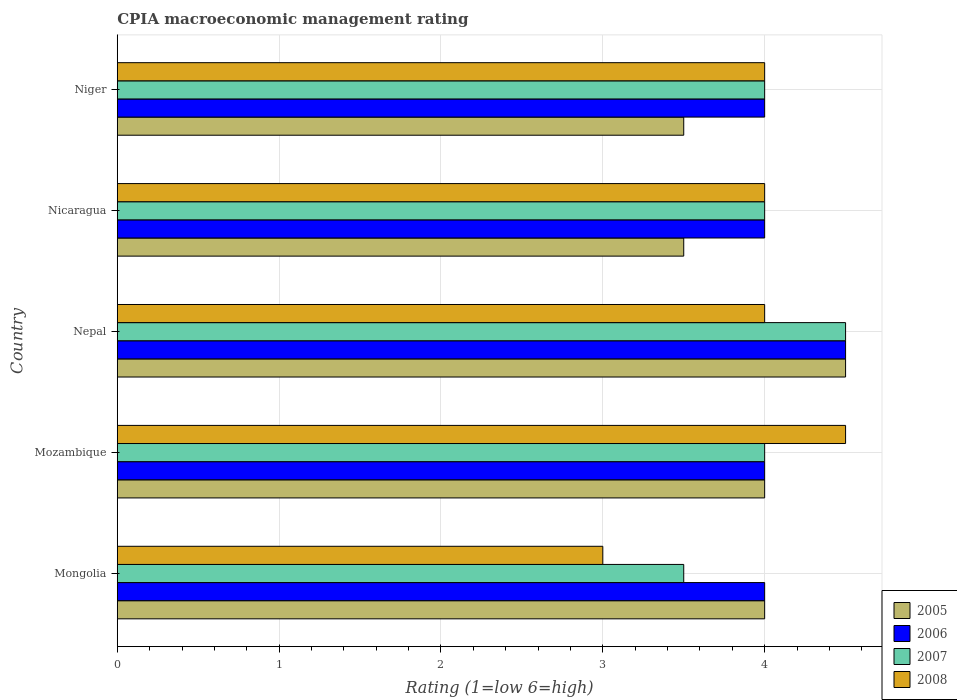Are the number of bars per tick equal to the number of legend labels?
Keep it short and to the point. Yes. How many bars are there on the 1st tick from the top?
Your answer should be compact. 4. What is the label of the 1st group of bars from the top?
Provide a succinct answer. Niger. In how many cases, is the number of bars for a given country not equal to the number of legend labels?
Offer a terse response. 0. In which country was the CPIA rating in 2007 maximum?
Your answer should be very brief. Nepal. In which country was the CPIA rating in 2007 minimum?
Give a very brief answer. Mongolia. What is the total CPIA rating in 2006 in the graph?
Provide a succinct answer. 20.5. In how many countries, is the CPIA rating in 2008 greater than 3 ?
Ensure brevity in your answer.  4. What is the ratio of the CPIA rating in 2005 in Nepal to that in Niger?
Ensure brevity in your answer.  1.29. What is the difference between the highest and the second highest CPIA rating in 2005?
Offer a very short reply. 0.5. What is the difference between the highest and the lowest CPIA rating in 2007?
Ensure brevity in your answer.  1. Is it the case that in every country, the sum of the CPIA rating in 2008 and CPIA rating in 2005 is greater than the sum of CPIA rating in 2006 and CPIA rating in 2007?
Provide a short and direct response. No. What does the 2nd bar from the bottom in Nepal represents?
Make the answer very short. 2006. Is it the case that in every country, the sum of the CPIA rating in 2006 and CPIA rating in 2005 is greater than the CPIA rating in 2007?
Ensure brevity in your answer.  Yes. What is the difference between two consecutive major ticks on the X-axis?
Your answer should be very brief. 1. Are the values on the major ticks of X-axis written in scientific E-notation?
Offer a very short reply. No. Does the graph contain any zero values?
Provide a short and direct response. No. Where does the legend appear in the graph?
Your response must be concise. Bottom right. How many legend labels are there?
Offer a terse response. 4. What is the title of the graph?
Your answer should be compact. CPIA macroeconomic management rating. Does "1993" appear as one of the legend labels in the graph?
Give a very brief answer. No. What is the label or title of the X-axis?
Offer a terse response. Rating (1=low 6=high). What is the Rating (1=low 6=high) in 2005 in Mongolia?
Keep it short and to the point. 4. What is the Rating (1=low 6=high) in 2008 in Mongolia?
Your answer should be compact. 3. What is the Rating (1=low 6=high) of 2007 in Mozambique?
Keep it short and to the point. 4. What is the Rating (1=low 6=high) in 2008 in Mozambique?
Make the answer very short. 4.5. What is the Rating (1=low 6=high) of 2006 in Nepal?
Offer a very short reply. 4.5. What is the Rating (1=low 6=high) of 2005 in Nicaragua?
Your response must be concise. 3.5. What is the Rating (1=low 6=high) in 2006 in Nicaragua?
Ensure brevity in your answer.  4. What is the Rating (1=low 6=high) in 2006 in Niger?
Your response must be concise. 4. What is the Rating (1=low 6=high) in 2008 in Niger?
Provide a succinct answer. 4. Across all countries, what is the maximum Rating (1=low 6=high) in 2006?
Your response must be concise. 4.5. Across all countries, what is the minimum Rating (1=low 6=high) in 2005?
Your response must be concise. 3.5. Across all countries, what is the minimum Rating (1=low 6=high) in 2007?
Your response must be concise. 3.5. What is the total Rating (1=low 6=high) in 2005 in the graph?
Your answer should be compact. 19.5. What is the total Rating (1=low 6=high) in 2006 in the graph?
Your response must be concise. 20.5. What is the difference between the Rating (1=low 6=high) of 2007 in Mongolia and that in Mozambique?
Make the answer very short. -0.5. What is the difference between the Rating (1=low 6=high) in 2005 in Mongolia and that in Nepal?
Offer a very short reply. -0.5. What is the difference between the Rating (1=low 6=high) in 2005 in Mongolia and that in Nicaragua?
Offer a very short reply. 0.5. What is the difference between the Rating (1=low 6=high) in 2005 in Mongolia and that in Niger?
Keep it short and to the point. 0.5. What is the difference between the Rating (1=low 6=high) in 2006 in Mongolia and that in Niger?
Offer a very short reply. 0. What is the difference between the Rating (1=low 6=high) in 2008 in Mongolia and that in Niger?
Your response must be concise. -1. What is the difference between the Rating (1=low 6=high) in 2005 in Mozambique and that in Nepal?
Ensure brevity in your answer.  -0.5. What is the difference between the Rating (1=low 6=high) in 2005 in Mozambique and that in Nicaragua?
Provide a succinct answer. 0.5. What is the difference between the Rating (1=low 6=high) of 2006 in Mozambique and that in Nicaragua?
Offer a terse response. 0. What is the difference between the Rating (1=low 6=high) of 2008 in Mozambique and that in Nicaragua?
Ensure brevity in your answer.  0.5. What is the difference between the Rating (1=low 6=high) in 2007 in Mozambique and that in Niger?
Provide a succinct answer. 0. What is the difference between the Rating (1=low 6=high) of 2008 in Nicaragua and that in Niger?
Provide a succinct answer. 0. What is the difference between the Rating (1=low 6=high) in 2005 in Mongolia and the Rating (1=low 6=high) in 2006 in Mozambique?
Offer a very short reply. 0. What is the difference between the Rating (1=low 6=high) of 2006 in Mongolia and the Rating (1=low 6=high) of 2008 in Mozambique?
Your response must be concise. -0.5. What is the difference between the Rating (1=low 6=high) in 2007 in Mongolia and the Rating (1=low 6=high) in 2008 in Mozambique?
Make the answer very short. -1. What is the difference between the Rating (1=low 6=high) of 2005 in Mongolia and the Rating (1=low 6=high) of 2006 in Nepal?
Your response must be concise. -0.5. What is the difference between the Rating (1=low 6=high) in 2005 in Mongolia and the Rating (1=low 6=high) in 2006 in Nicaragua?
Keep it short and to the point. 0. What is the difference between the Rating (1=low 6=high) in 2005 in Mongolia and the Rating (1=low 6=high) in 2007 in Nicaragua?
Make the answer very short. 0. What is the difference between the Rating (1=low 6=high) of 2006 in Mongolia and the Rating (1=low 6=high) of 2008 in Nicaragua?
Offer a very short reply. 0. What is the difference between the Rating (1=low 6=high) of 2007 in Mongolia and the Rating (1=low 6=high) of 2008 in Nicaragua?
Your answer should be very brief. -0.5. What is the difference between the Rating (1=low 6=high) in 2005 in Mongolia and the Rating (1=low 6=high) in 2007 in Niger?
Provide a succinct answer. 0. What is the difference between the Rating (1=low 6=high) in 2006 in Mongolia and the Rating (1=low 6=high) in 2007 in Niger?
Your answer should be very brief. 0. What is the difference between the Rating (1=low 6=high) in 2006 in Mongolia and the Rating (1=low 6=high) in 2008 in Niger?
Provide a short and direct response. 0. What is the difference between the Rating (1=low 6=high) of 2005 in Mozambique and the Rating (1=low 6=high) of 2007 in Nepal?
Make the answer very short. -0.5. What is the difference between the Rating (1=low 6=high) of 2005 in Mozambique and the Rating (1=low 6=high) of 2008 in Nepal?
Keep it short and to the point. 0. What is the difference between the Rating (1=low 6=high) in 2006 in Mozambique and the Rating (1=low 6=high) in 2007 in Nepal?
Provide a succinct answer. -0.5. What is the difference between the Rating (1=low 6=high) in 2006 in Mozambique and the Rating (1=low 6=high) in 2008 in Nepal?
Ensure brevity in your answer.  0. What is the difference between the Rating (1=low 6=high) in 2007 in Mozambique and the Rating (1=low 6=high) in 2008 in Nepal?
Offer a very short reply. 0. What is the difference between the Rating (1=low 6=high) in 2005 in Mozambique and the Rating (1=low 6=high) in 2007 in Nicaragua?
Keep it short and to the point. 0. What is the difference between the Rating (1=low 6=high) in 2005 in Mozambique and the Rating (1=low 6=high) in 2008 in Nicaragua?
Keep it short and to the point. 0. What is the difference between the Rating (1=low 6=high) of 2006 in Mozambique and the Rating (1=low 6=high) of 2007 in Nicaragua?
Your answer should be compact. 0. What is the difference between the Rating (1=low 6=high) in 2006 in Mozambique and the Rating (1=low 6=high) in 2008 in Nicaragua?
Provide a short and direct response. 0. What is the difference between the Rating (1=low 6=high) in 2007 in Mozambique and the Rating (1=low 6=high) in 2008 in Nicaragua?
Offer a terse response. 0. What is the difference between the Rating (1=low 6=high) of 2005 in Mozambique and the Rating (1=low 6=high) of 2007 in Niger?
Provide a short and direct response. 0. What is the difference between the Rating (1=low 6=high) in 2005 in Mozambique and the Rating (1=low 6=high) in 2008 in Niger?
Provide a succinct answer. 0. What is the difference between the Rating (1=low 6=high) in 2005 in Nepal and the Rating (1=low 6=high) in 2007 in Nicaragua?
Provide a short and direct response. 0.5. What is the difference between the Rating (1=low 6=high) in 2005 in Nepal and the Rating (1=low 6=high) in 2008 in Nicaragua?
Provide a short and direct response. 0.5. What is the difference between the Rating (1=low 6=high) in 2006 in Nepal and the Rating (1=low 6=high) in 2008 in Nicaragua?
Give a very brief answer. 0.5. What is the difference between the Rating (1=low 6=high) in 2005 in Nepal and the Rating (1=low 6=high) in 2006 in Niger?
Offer a very short reply. 0.5. What is the difference between the Rating (1=low 6=high) of 2005 in Nepal and the Rating (1=low 6=high) of 2008 in Niger?
Your response must be concise. 0.5. What is the difference between the Rating (1=low 6=high) in 2006 in Nepal and the Rating (1=low 6=high) in 2007 in Niger?
Your answer should be compact. 0.5. What is the difference between the Rating (1=low 6=high) in 2007 in Nepal and the Rating (1=low 6=high) in 2008 in Niger?
Ensure brevity in your answer.  0.5. What is the difference between the Rating (1=low 6=high) of 2005 in Nicaragua and the Rating (1=low 6=high) of 2007 in Niger?
Provide a short and direct response. -0.5. What is the difference between the Rating (1=low 6=high) of 2005 in Nicaragua and the Rating (1=low 6=high) of 2008 in Niger?
Your answer should be compact. -0.5. What is the difference between the Rating (1=low 6=high) in 2007 in Nicaragua and the Rating (1=low 6=high) in 2008 in Niger?
Keep it short and to the point. 0. What is the average Rating (1=low 6=high) of 2006 per country?
Ensure brevity in your answer.  4.1. What is the difference between the Rating (1=low 6=high) in 2005 and Rating (1=low 6=high) in 2006 in Mongolia?
Your response must be concise. 0. What is the difference between the Rating (1=low 6=high) of 2006 and Rating (1=low 6=high) of 2008 in Mongolia?
Keep it short and to the point. 1. What is the difference between the Rating (1=low 6=high) of 2007 and Rating (1=low 6=high) of 2008 in Mongolia?
Provide a succinct answer. 0.5. What is the difference between the Rating (1=low 6=high) in 2005 and Rating (1=low 6=high) in 2007 in Mozambique?
Provide a succinct answer. 0. What is the difference between the Rating (1=low 6=high) of 2005 and Rating (1=low 6=high) of 2008 in Mozambique?
Give a very brief answer. -0.5. What is the difference between the Rating (1=low 6=high) in 2006 and Rating (1=low 6=high) in 2007 in Mozambique?
Make the answer very short. 0. What is the difference between the Rating (1=low 6=high) of 2007 and Rating (1=low 6=high) of 2008 in Mozambique?
Make the answer very short. -0.5. What is the difference between the Rating (1=low 6=high) in 2005 and Rating (1=low 6=high) in 2006 in Nepal?
Give a very brief answer. 0. What is the difference between the Rating (1=low 6=high) of 2006 and Rating (1=low 6=high) of 2008 in Nepal?
Keep it short and to the point. 0.5. What is the difference between the Rating (1=low 6=high) of 2006 and Rating (1=low 6=high) of 2008 in Nicaragua?
Ensure brevity in your answer.  0. What is the difference between the Rating (1=low 6=high) in 2005 and Rating (1=low 6=high) in 2006 in Niger?
Your answer should be very brief. -0.5. What is the difference between the Rating (1=low 6=high) of 2005 and Rating (1=low 6=high) of 2007 in Niger?
Make the answer very short. -0.5. What is the difference between the Rating (1=low 6=high) in 2006 and Rating (1=low 6=high) in 2008 in Niger?
Provide a short and direct response. 0. What is the difference between the Rating (1=low 6=high) in 2007 and Rating (1=low 6=high) in 2008 in Niger?
Make the answer very short. 0. What is the ratio of the Rating (1=low 6=high) of 2007 in Mongolia to that in Mozambique?
Your answer should be very brief. 0.88. What is the ratio of the Rating (1=low 6=high) in 2005 in Mongolia to that in Nepal?
Offer a terse response. 0.89. What is the ratio of the Rating (1=low 6=high) of 2006 in Mongolia to that in Nepal?
Ensure brevity in your answer.  0.89. What is the ratio of the Rating (1=low 6=high) of 2007 in Mongolia to that in Nepal?
Give a very brief answer. 0.78. What is the ratio of the Rating (1=low 6=high) in 2008 in Mongolia to that in Nepal?
Your response must be concise. 0.75. What is the ratio of the Rating (1=low 6=high) of 2005 in Mongolia to that in Nicaragua?
Keep it short and to the point. 1.14. What is the ratio of the Rating (1=low 6=high) of 2008 in Mongolia to that in Nicaragua?
Provide a short and direct response. 0.75. What is the ratio of the Rating (1=low 6=high) of 2005 in Mongolia to that in Niger?
Your answer should be very brief. 1.14. What is the ratio of the Rating (1=low 6=high) in 2006 in Mongolia to that in Niger?
Your response must be concise. 1. What is the ratio of the Rating (1=low 6=high) of 2007 in Mongolia to that in Niger?
Ensure brevity in your answer.  0.88. What is the ratio of the Rating (1=low 6=high) in 2006 in Mozambique to that in Nepal?
Your answer should be very brief. 0.89. What is the ratio of the Rating (1=low 6=high) in 2007 in Mozambique to that in Nepal?
Your answer should be very brief. 0.89. What is the ratio of the Rating (1=low 6=high) in 2008 in Mozambique to that in Nepal?
Your answer should be compact. 1.12. What is the ratio of the Rating (1=low 6=high) of 2006 in Mozambique to that in Nicaragua?
Make the answer very short. 1. What is the ratio of the Rating (1=low 6=high) in 2007 in Mozambique to that in Nicaragua?
Keep it short and to the point. 1. What is the ratio of the Rating (1=low 6=high) in 2008 in Mozambique to that in Nicaragua?
Provide a short and direct response. 1.12. What is the ratio of the Rating (1=low 6=high) in 2005 in Mozambique to that in Niger?
Give a very brief answer. 1.14. What is the ratio of the Rating (1=low 6=high) of 2006 in Mozambique to that in Niger?
Provide a short and direct response. 1. What is the ratio of the Rating (1=low 6=high) of 2007 in Mozambique to that in Niger?
Keep it short and to the point. 1. What is the ratio of the Rating (1=low 6=high) in 2008 in Mozambique to that in Niger?
Ensure brevity in your answer.  1.12. What is the ratio of the Rating (1=low 6=high) in 2005 in Nepal to that in Nicaragua?
Provide a succinct answer. 1.29. What is the ratio of the Rating (1=low 6=high) in 2006 in Nepal to that in Nicaragua?
Your answer should be compact. 1.12. What is the ratio of the Rating (1=low 6=high) of 2008 in Nepal to that in Nicaragua?
Ensure brevity in your answer.  1. What is the ratio of the Rating (1=low 6=high) in 2005 in Nepal to that in Niger?
Give a very brief answer. 1.29. What is the ratio of the Rating (1=low 6=high) of 2007 in Nepal to that in Niger?
Your response must be concise. 1.12. What is the difference between the highest and the second highest Rating (1=low 6=high) of 2005?
Make the answer very short. 0.5. What is the difference between the highest and the second highest Rating (1=low 6=high) in 2008?
Provide a succinct answer. 0.5. What is the difference between the highest and the lowest Rating (1=low 6=high) of 2005?
Your answer should be very brief. 1. 